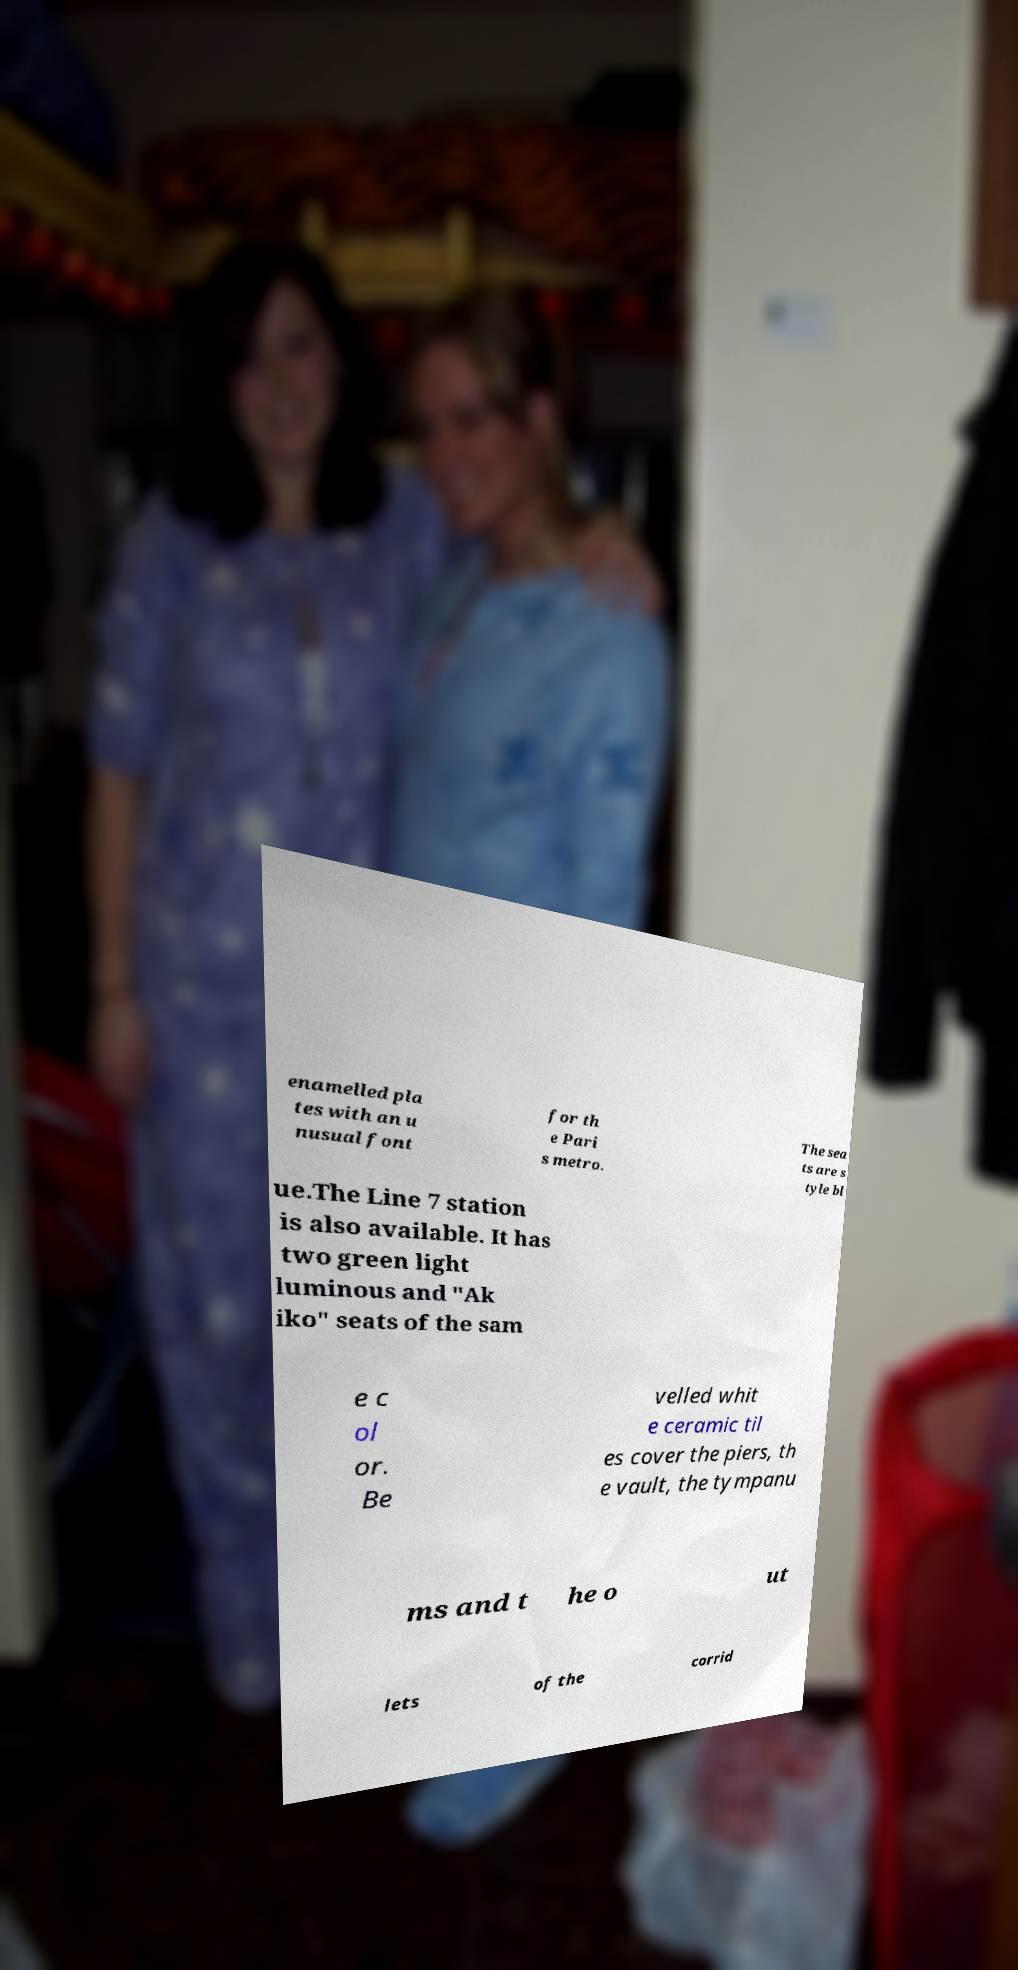Could you extract and type out the text from this image? enamelled pla tes with an u nusual font for th e Pari s metro. The sea ts are s tyle bl ue.The Line 7 station is also available. It has two green light luminous and "Ak iko" seats of the sam e c ol or. Be velled whit e ceramic til es cover the piers, th e vault, the tympanu ms and t he o ut lets of the corrid 